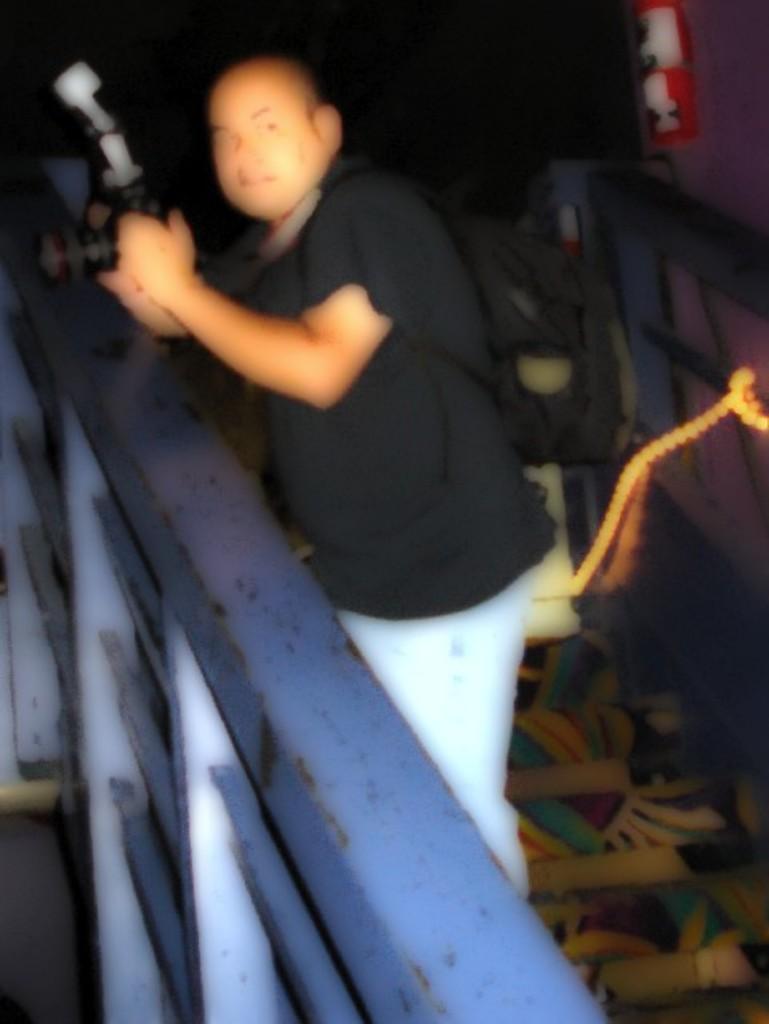Can you describe this image briefly? This is a blur image. In the image on the left side there is a railing. Behind the railing there is a man standing and holding a camera in the hand. Behind him there is a wall with lights and some other things. 